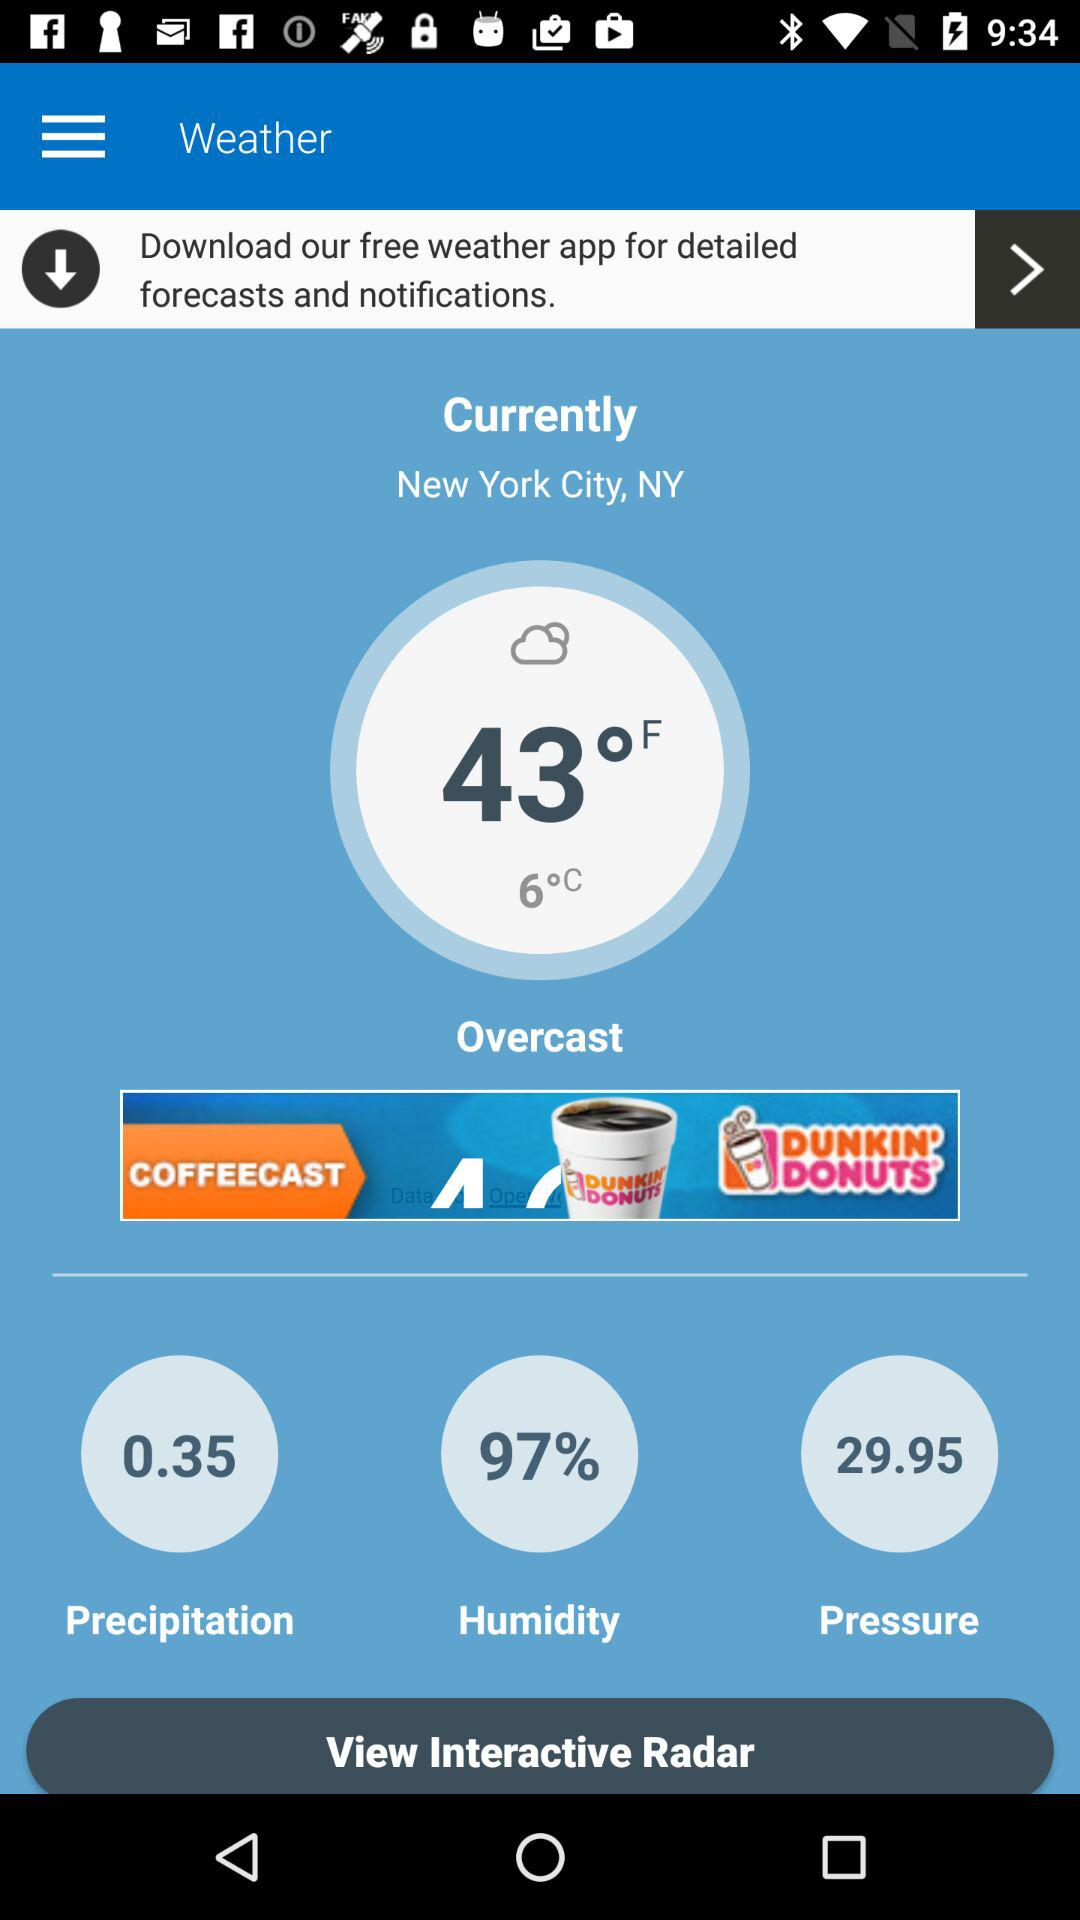How many degrees Fahrenheit is it today?
Answer the question using a single word or phrase. 43°F 